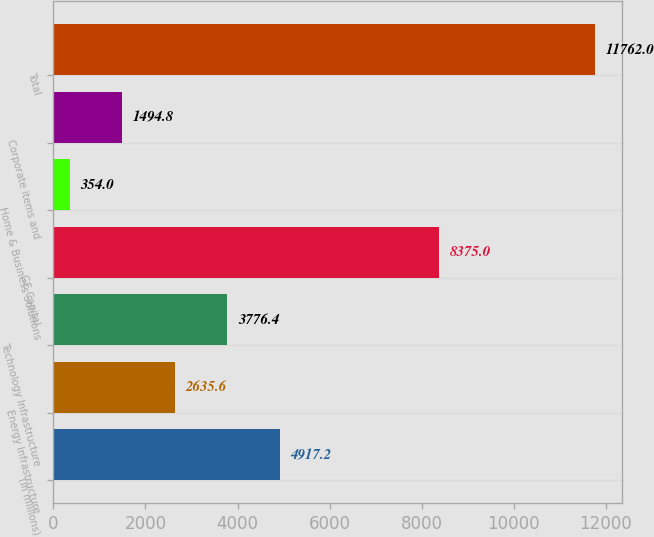Convert chart. <chart><loc_0><loc_0><loc_500><loc_500><bar_chart><fcel>(In millions)<fcel>Energy Infrastructure<fcel>Technology Infrastructure<fcel>GE Capital<fcel>Home & Business Solutions<fcel>Corporate items and<fcel>Total<nl><fcel>4917.2<fcel>2635.6<fcel>3776.4<fcel>8375<fcel>354<fcel>1494.8<fcel>11762<nl></chart> 